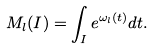Convert formula to latex. <formula><loc_0><loc_0><loc_500><loc_500>M _ { l } ( I ) = \int _ { I } e ^ { \omega _ { l } ( t ) } d t .</formula> 